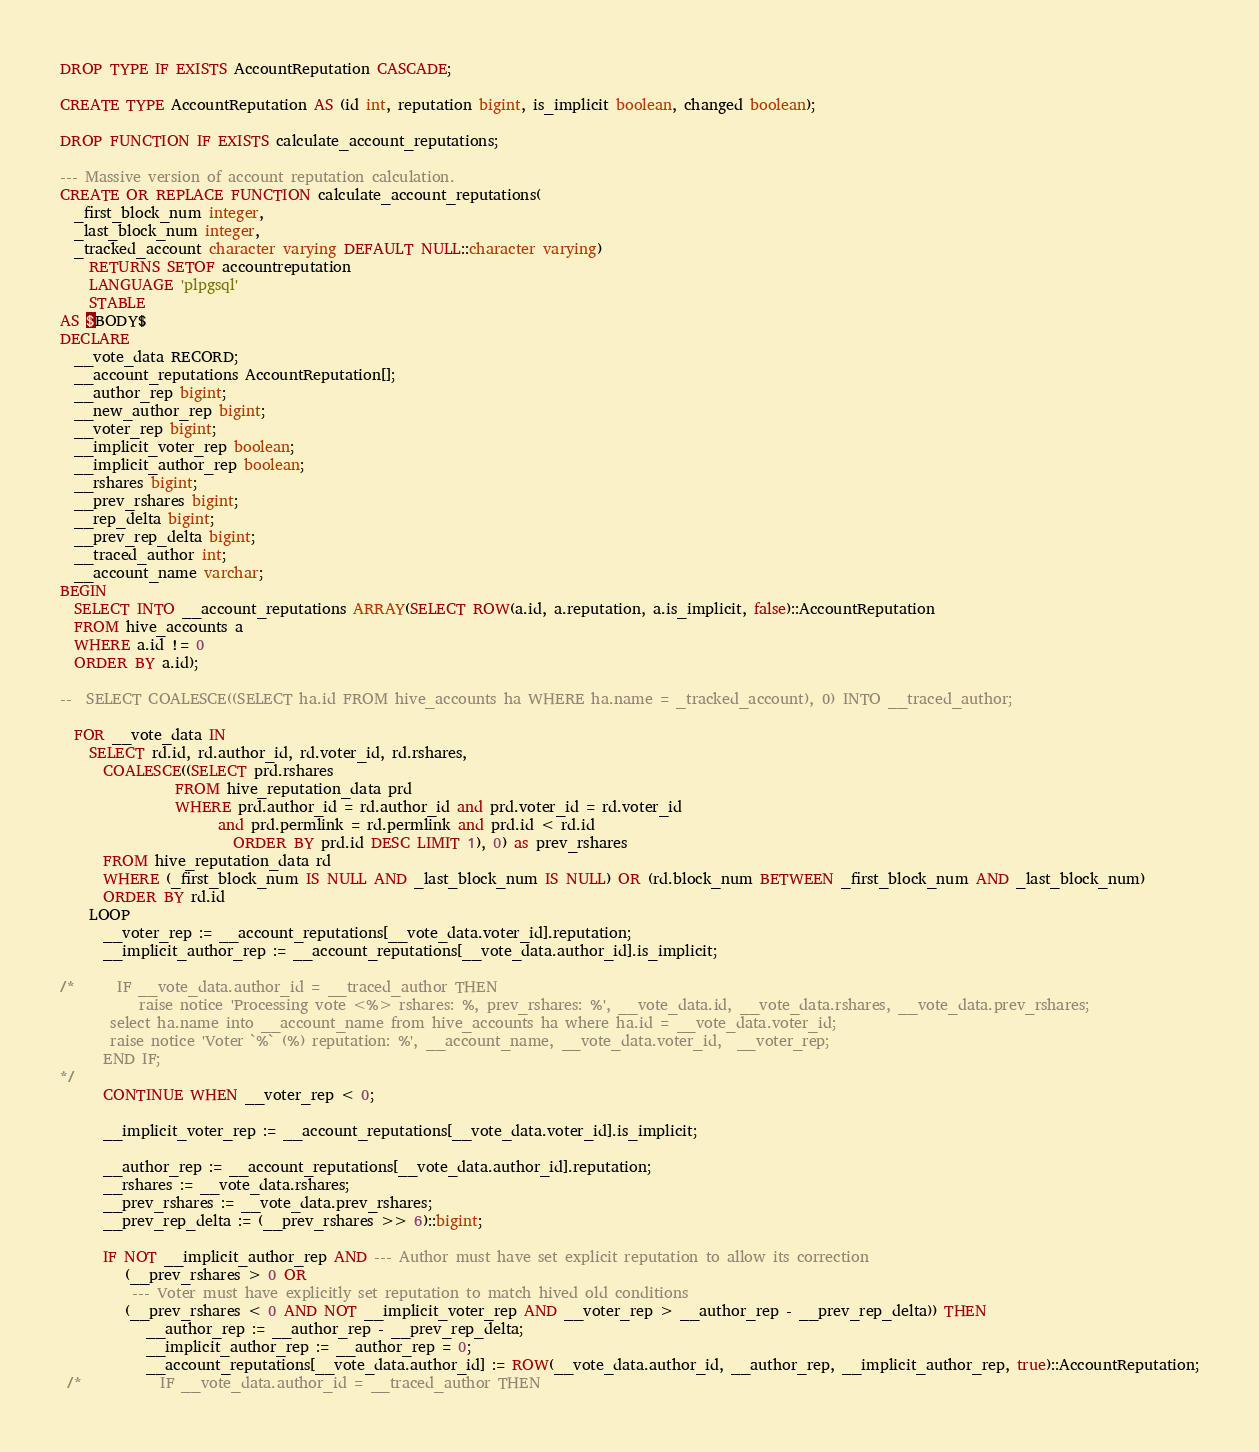Convert code to text. <code><loc_0><loc_0><loc_500><loc_500><_SQL_>DROP TYPE IF EXISTS AccountReputation CASCADE;

CREATE TYPE AccountReputation AS (id int, reputation bigint, is_implicit boolean, changed boolean);

DROP FUNCTION IF EXISTS calculate_account_reputations;

--- Massive version of account reputation calculation.
CREATE OR REPLACE FUNCTION calculate_account_reputations(
  _first_block_num integer,
  _last_block_num integer,
  _tracked_account character varying DEFAULT NULL::character varying)
    RETURNS SETOF accountreputation 
    LANGUAGE 'plpgsql'
    STABLE 
AS $BODY$
DECLARE
  __vote_data RECORD;
  __account_reputations AccountReputation[];
  __author_rep bigint;
  __new_author_rep bigint;
  __voter_rep bigint;
  __implicit_voter_rep boolean;
  __implicit_author_rep boolean;
  __rshares bigint;
  __prev_rshares bigint;
  __rep_delta bigint;
  __prev_rep_delta bigint;
  __traced_author int;
  __account_name varchar;
BEGIN
  SELECT INTO __account_reputations ARRAY(SELECT ROW(a.id, a.reputation, a.is_implicit, false)::AccountReputation
  FROM hive_accounts a
  WHERE a.id != 0
  ORDER BY a.id);

--  SELECT COALESCE((SELECT ha.id FROM hive_accounts ha WHERE ha.name = _tracked_account), 0) INTO __traced_author;

  FOR __vote_data IN
    SELECT rd.id, rd.author_id, rd.voter_id, rd.rshares,
      COALESCE((SELECT prd.rshares
                FROM hive_reputation_data prd
                WHERE prd.author_id = rd.author_id and prd.voter_id = rd.voter_id
                      and prd.permlink = rd.permlink and prd.id < rd.id
                        ORDER BY prd.id DESC LIMIT 1), 0) as prev_rshares
      FROM hive_reputation_data rd 
      WHERE (_first_block_num IS NULL AND _last_block_num IS NULL) OR (rd.block_num BETWEEN _first_block_num AND _last_block_num)
      ORDER BY rd.id
    LOOP
      __voter_rep := __account_reputations[__vote_data.voter_id].reputation;
      __implicit_author_rep := __account_reputations[__vote_data.author_id].is_implicit;
    
/*      IF __vote_data.author_id = __traced_author THEN
           raise notice 'Processing vote <%> rshares: %, prev_rshares: %', __vote_data.id, __vote_data.rshares, __vote_data.prev_rshares;
       select ha.name into __account_name from hive_accounts ha where ha.id = __vote_data.voter_id;
       raise notice 'Voter `%` (%) reputation: %', __account_name, __vote_data.voter_id,  __voter_rep;
      END IF;
*/
      CONTINUE WHEN __voter_rep < 0;

      __implicit_voter_rep := __account_reputations[__vote_data.voter_id].is_implicit;
    
      __author_rep := __account_reputations[__vote_data.author_id].reputation;
      __rshares := __vote_data.rshares;
      __prev_rshares := __vote_data.prev_rshares;
      __prev_rep_delta := (__prev_rshares >> 6)::bigint;

      IF NOT __implicit_author_rep AND --- Author must have set explicit reputation to allow its correction
         (__prev_rshares > 0 OR
          --- Voter must have explicitly set reputation to match hived old conditions
         (__prev_rshares < 0 AND NOT __implicit_voter_rep AND __voter_rep > __author_rep - __prev_rep_delta)) THEN
            __author_rep := __author_rep - __prev_rep_delta;
            __implicit_author_rep := __author_rep = 0;
            __account_reputations[__vote_data.author_id] := ROW(__vote_data.author_id, __author_rep, __implicit_author_rep, true)::AccountReputation;
 /*           IF __vote_data.author_id = __traced_author THEN</code> 